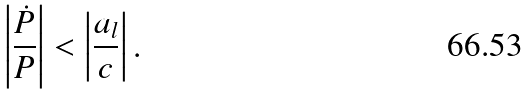Convert formula to latex. <formula><loc_0><loc_0><loc_500><loc_500>\left | \frac { \dot { P } } { P } \right | < \left | \frac { a _ { l } } { c } \right | .</formula> 